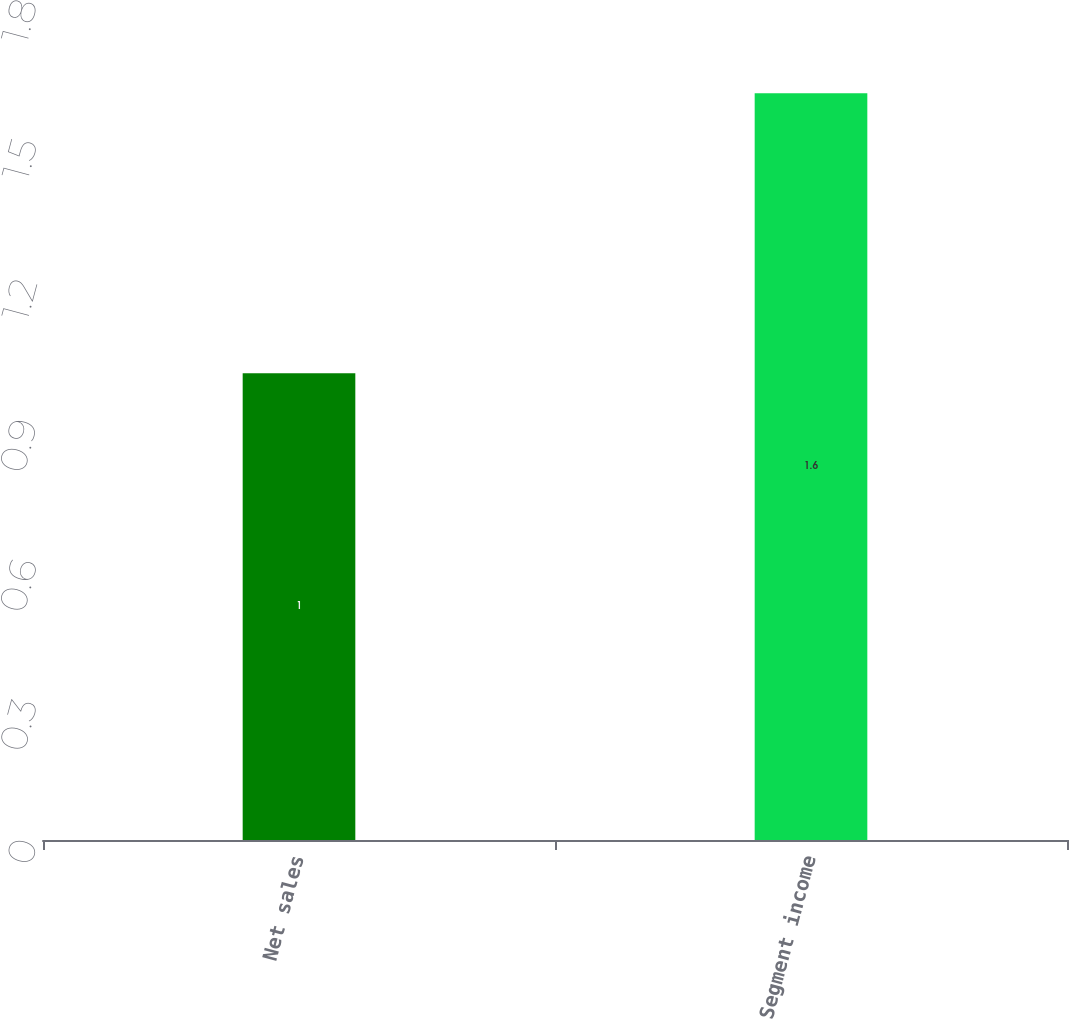Convert chart to OTSL. <chart><loc_0><loc_0><loc_500><loc_500><bar_chart><fcel>Net sales<fcel>Segment income<nl><fcel>1<fcel>1.6<nl></chart> 